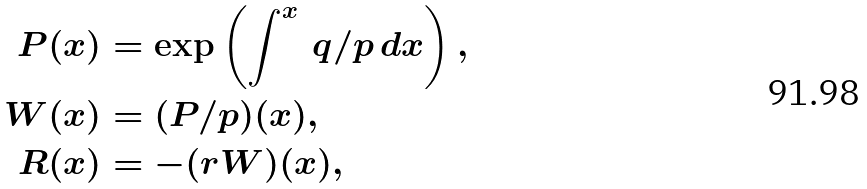<formula> <loc_0><loc_0><loc_500><loc_500>P ( x ) & = \exp \left ( \int ^ { x } \, q / p \, d x \right ) , \\ W ( x ) & = ( P / p ) ( x ) , \\ R ( x ) & = - ( r W ) ( x ) ,</formula> 